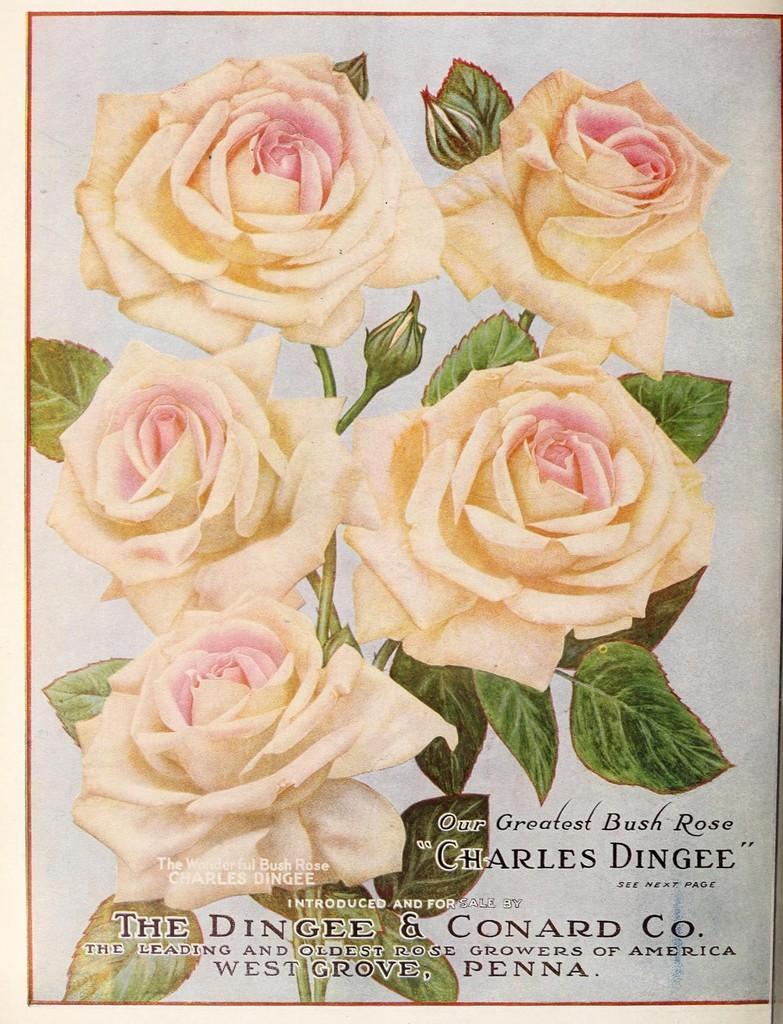Please provide a concise description of this image. This looks like a poster. I can see a plant with five rose flowers, buds and leaves. These rose flowers are white and pinkish in color. I can see the letters in the image. 